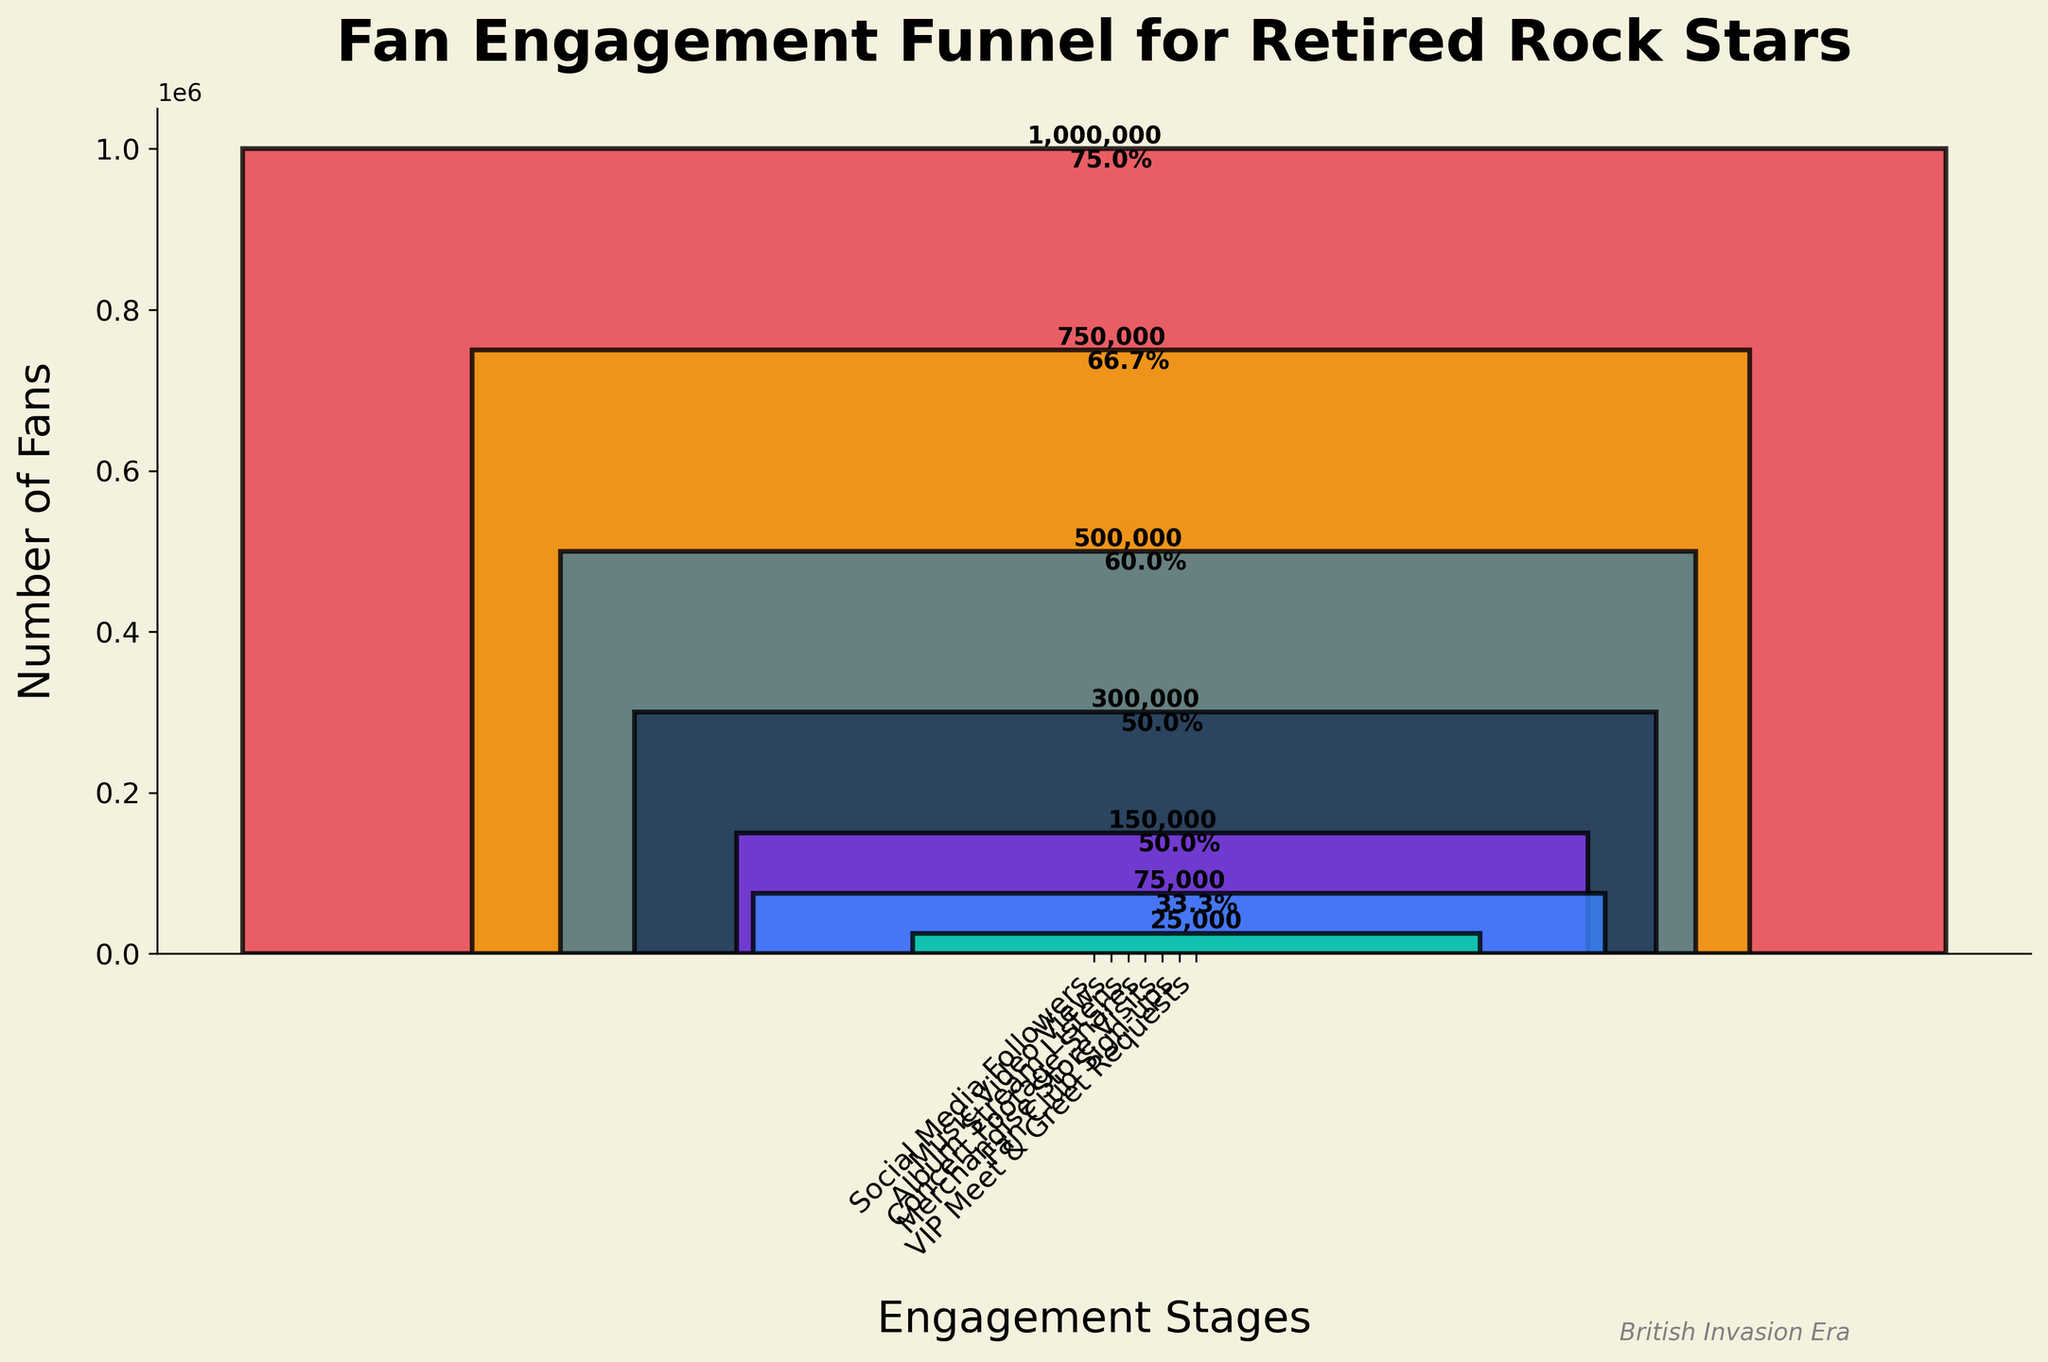What is the title of the chart? The title is usually placed at the top of the chart. Here, it reads "Fan Engagement Funnel for Retired Rock Stars".
Answer: Fan Engagement Funnel for Retired Rock Stars How many engagement stages are shown in the funnel? By counting the unique engagement stages on the x-axis, we can see that there are seven stages.
Answer: Seven What is the number of Social Media Followers? The first bar in the funnel chart represents the "Social Media Followers" stage, which shows 1,000,000 fans.
Answer: 1,000,000 Which stage has the fewest number of fans? By examining the bar heights and values, the "VIP Meet & Greet Requests" stage has the lowest number of fans, which is 25,000.
Answer: VIP Meet & Greet Requests How many fans are there at the Album Stream Listens stage? The bar labeled "Album Stream Listens" has a value, which is 500,000 fans.
Answer: 500,000 What percentage of fans went from Music Video Views to Album Stream Listens? The values are 750,000 for Music Video Views and 500,000 for Album Stream Listens. The percentage is calculated as (500,000 / 750,000) * 100 = 66.7%.
Answer: 66.7% What is the sum of fans at the Concert Footage Shares and Merchandise Store Visits stages? Adding the fans from these two stages: 300,000 (Concert Footage Shares) + 150,000 (Merchandise Store Visits) = 450,000.
Answer: 450,000 Which stage has a higher number of fans: Fan Club Sign-ups or Merchandise Store Visits? Comparing the two values, Fan Club Sign-ups has 75,000 and Merchandise Store Visits has 150,000. Merchandise Store Visits has more fans.
Answer: Merchandise Store Visits What is the difference in the number of fans between Social Media Followers and VIP Meet & Greet Requests? Subtracting the number of VIP Meet & Greet Requests (25,000) from Social Media Followers (1,000,000) gives: 1,000,000 - 25,000 = 975,000.
Answer: 975,000 Which color represents the "Fan Club Sign-ups" stage? The bar representing "Fan Club Sign-ups" is colored in a shade of purple, often recognized from rock album covers.
Answer: Purple 